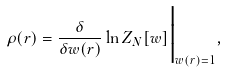<formula> <loc_0><loc_0><loc_500><loc_500>\rho ( { r } ) = \frac { \delta } { \delta w ( { r } ) } \ln Z _ { N } [ w ] \Big | _ { w ( { r } ) = 1 } ,</formula> 